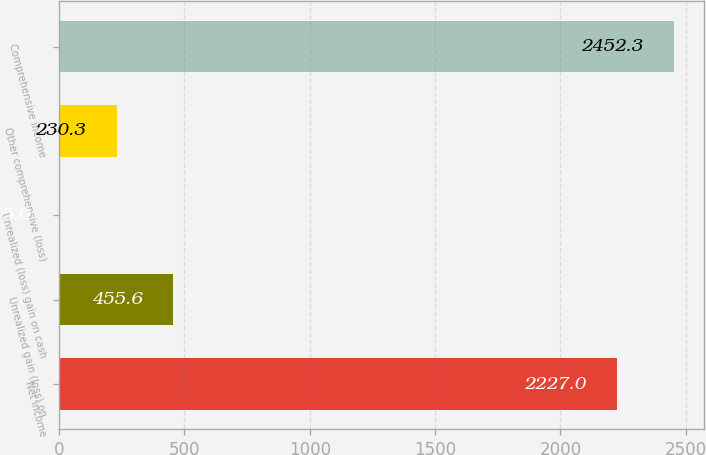<chart> <loc_0><loc_0><loc_500><loc_500><bar_chart><fcel>Net income<fcel>Unrealized gain (loss) on<fcel>Unrealized (loss) gain on cash<fcel>Other comprehensive (loss)<fcel>Comprehensive income<nl><fcel>2227<fcel>455.6<fcel>5<fcel>230.3<fcel>2452.3<nl></chart> 